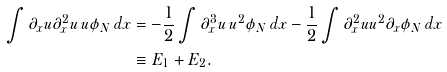<formula> <loc_0><loc_0><loc_500><loc_500>\int \partial _ { x } u \partial _ { x } ^ { 2 } u \, u \phi _ { N } \, d x & = - \frac { 1 } { 2 } \int \partial _ { x } ^ { 3 } u \, u ^ { 2 } \phi _ { N } \, d x - \frac { 1 } { 2 } \int \partial _ { x } ^ { 2 } u u ^ { 2 } \partial _ { x } \phi _ { N } \, d x \\ & \equiv E _ { 1 } + E _ { 2 } .</formula> 